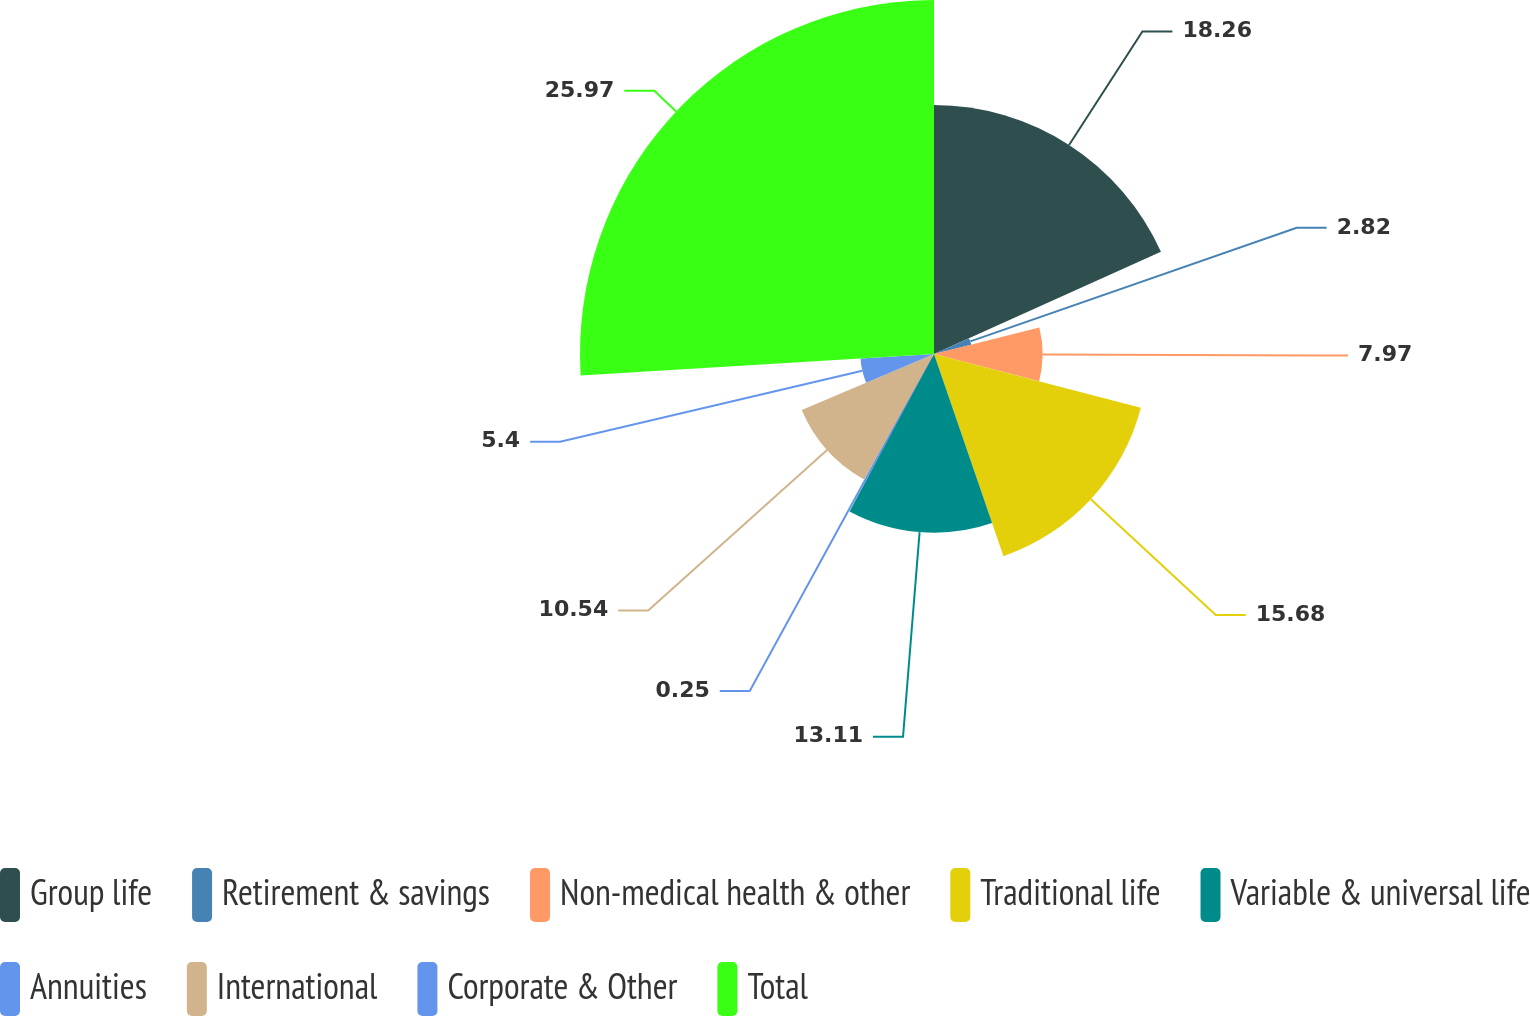<chart> <loc_0><loc_0><loc_500><loc_500><pie_chart><fcel>Group life<fcel>Retirement & savings<fcel>Non-medical health & other<fcel>Traditional life<fcel>Variable & universal life<fcel>Annuities<fcel>International<fcel>Corporate & Other<fcel>Total<nl><fcel>18.26%<fcel>2.82%<fcel>7.97%<fcel>15.68%<fcel>13.11%<fcel>0.25%<fcel>10.54%<fcel>5.4%<fcel>25.97%<nl></chart> 